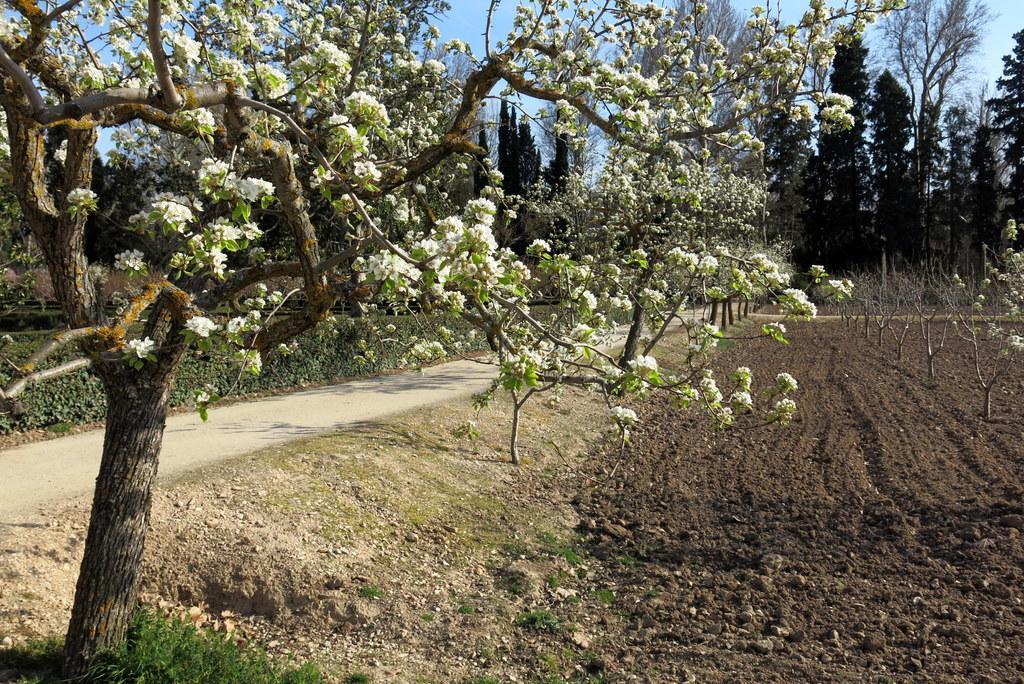Could you give a brief overview of what you see in this image? In the picture I can see a tree which has few white flowers on it and there is a road beside it and there are trees in the background. 